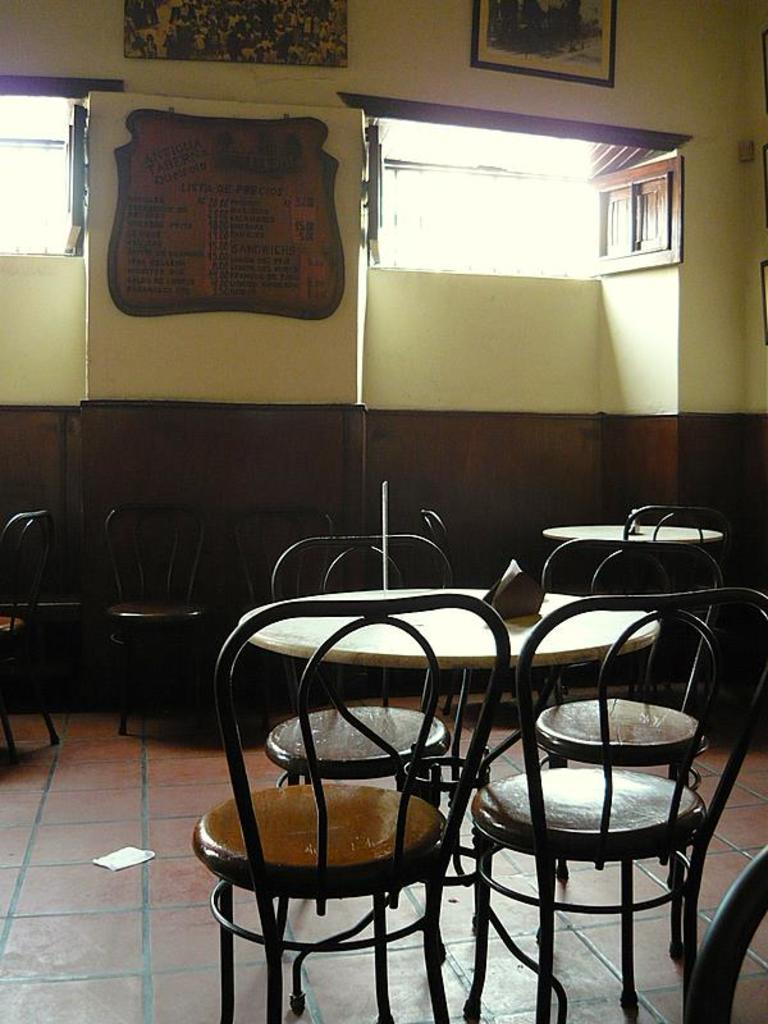What type of furniture can be seen in the image? There are chairs in the image. What can be found on the tables in the image? There are tissue holders on the tables. What architectural feature is visible in the image? There are windows visible in the image. What type of decorative items are present in the image? There are frames in the image. What is attached to the wall in the image? There is a board attached to the wall. How many women are present in the image? There is no mention of women in the provided facts, so we cannot determine the number of women in the image. What type of grape is being used as a decoration in the image? There is no mention of grapes in the provided facts, so we cannot determine if any grapes are present in the image. 